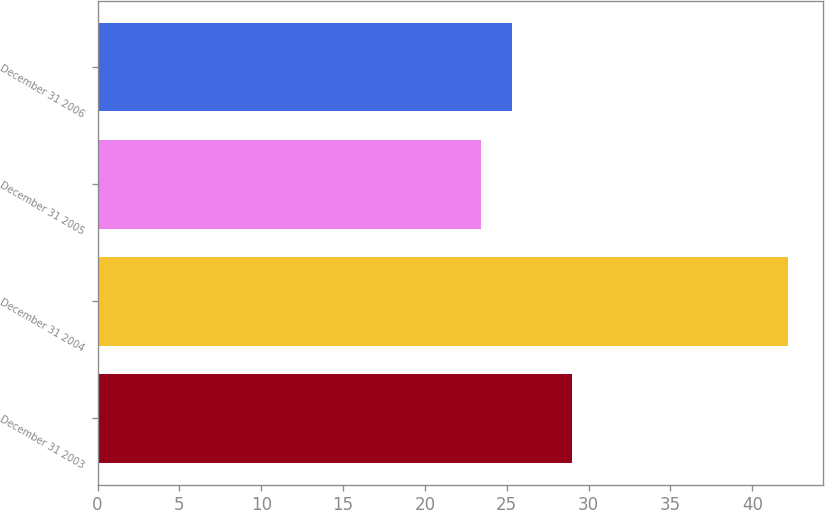<chart> <loc_0><loc_0><loc_500><loc_500><bar_chart><fcel>December 31 2003<fcel>December 31 2004<fcel>December 31 2005<fcel>December 31 2006<nl><fcel>29<fcel>42.2<fcel>23.4<fcel>25.3<nl></chart> 